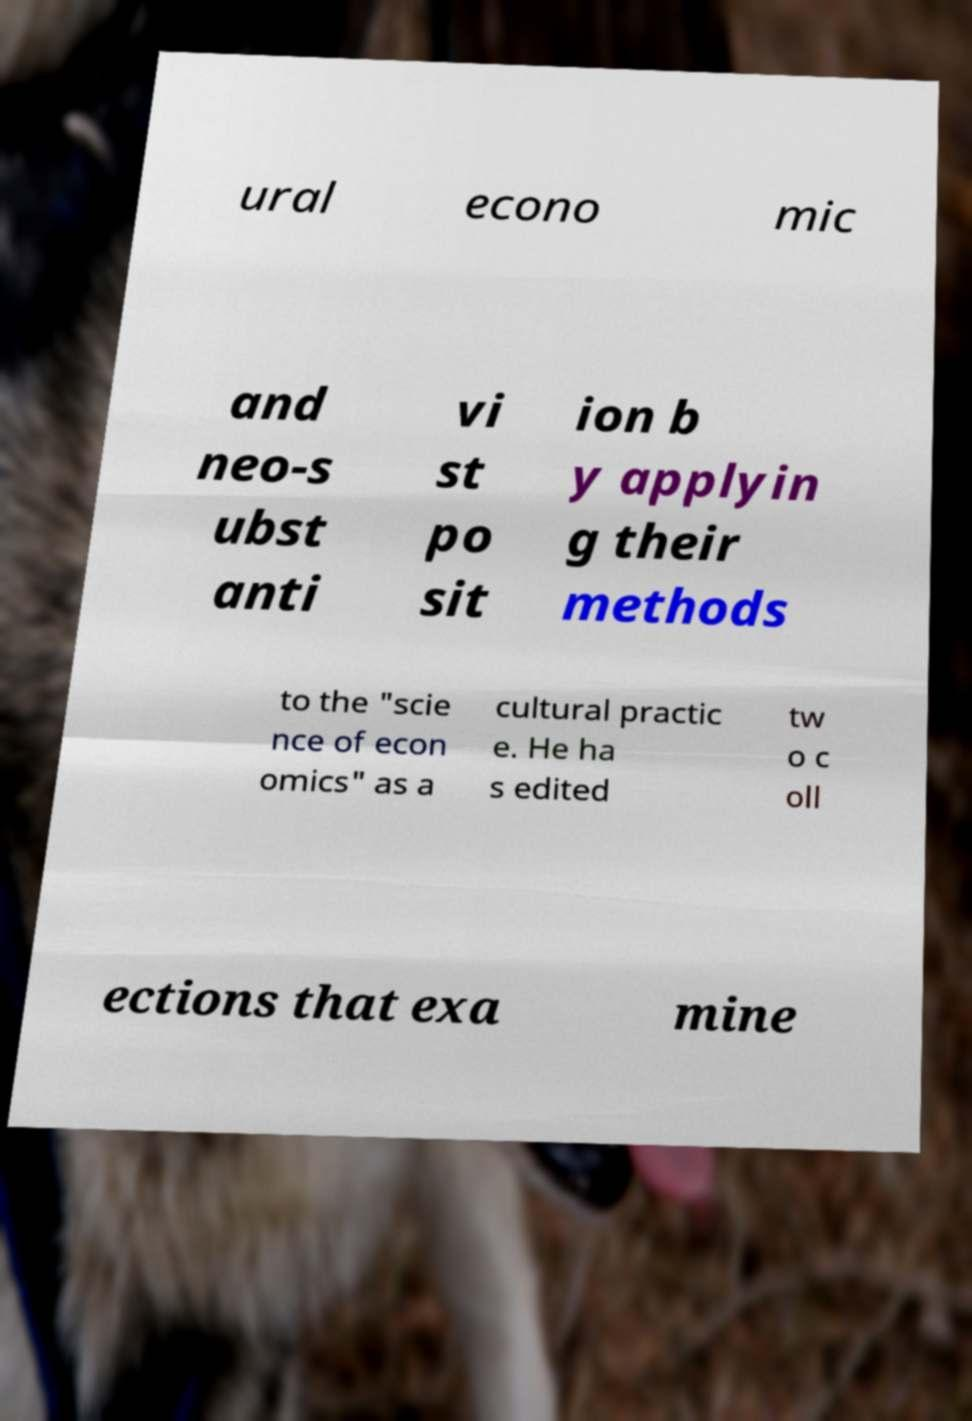Could you assist in decoding the text presented in this image and type it out clearly? ural econo mic and neo-s ubst anti vi st po sit ion b y applyin g their methods to the "scie nce of econ omics" as a cultural practic e. He ha s edited tw o c oll ections that exa mine 